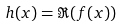<formula> <loc_0><loc_0><loc_500><loc_500>h ( x ) = \Re { ( f ( x ) ) }</formula> 